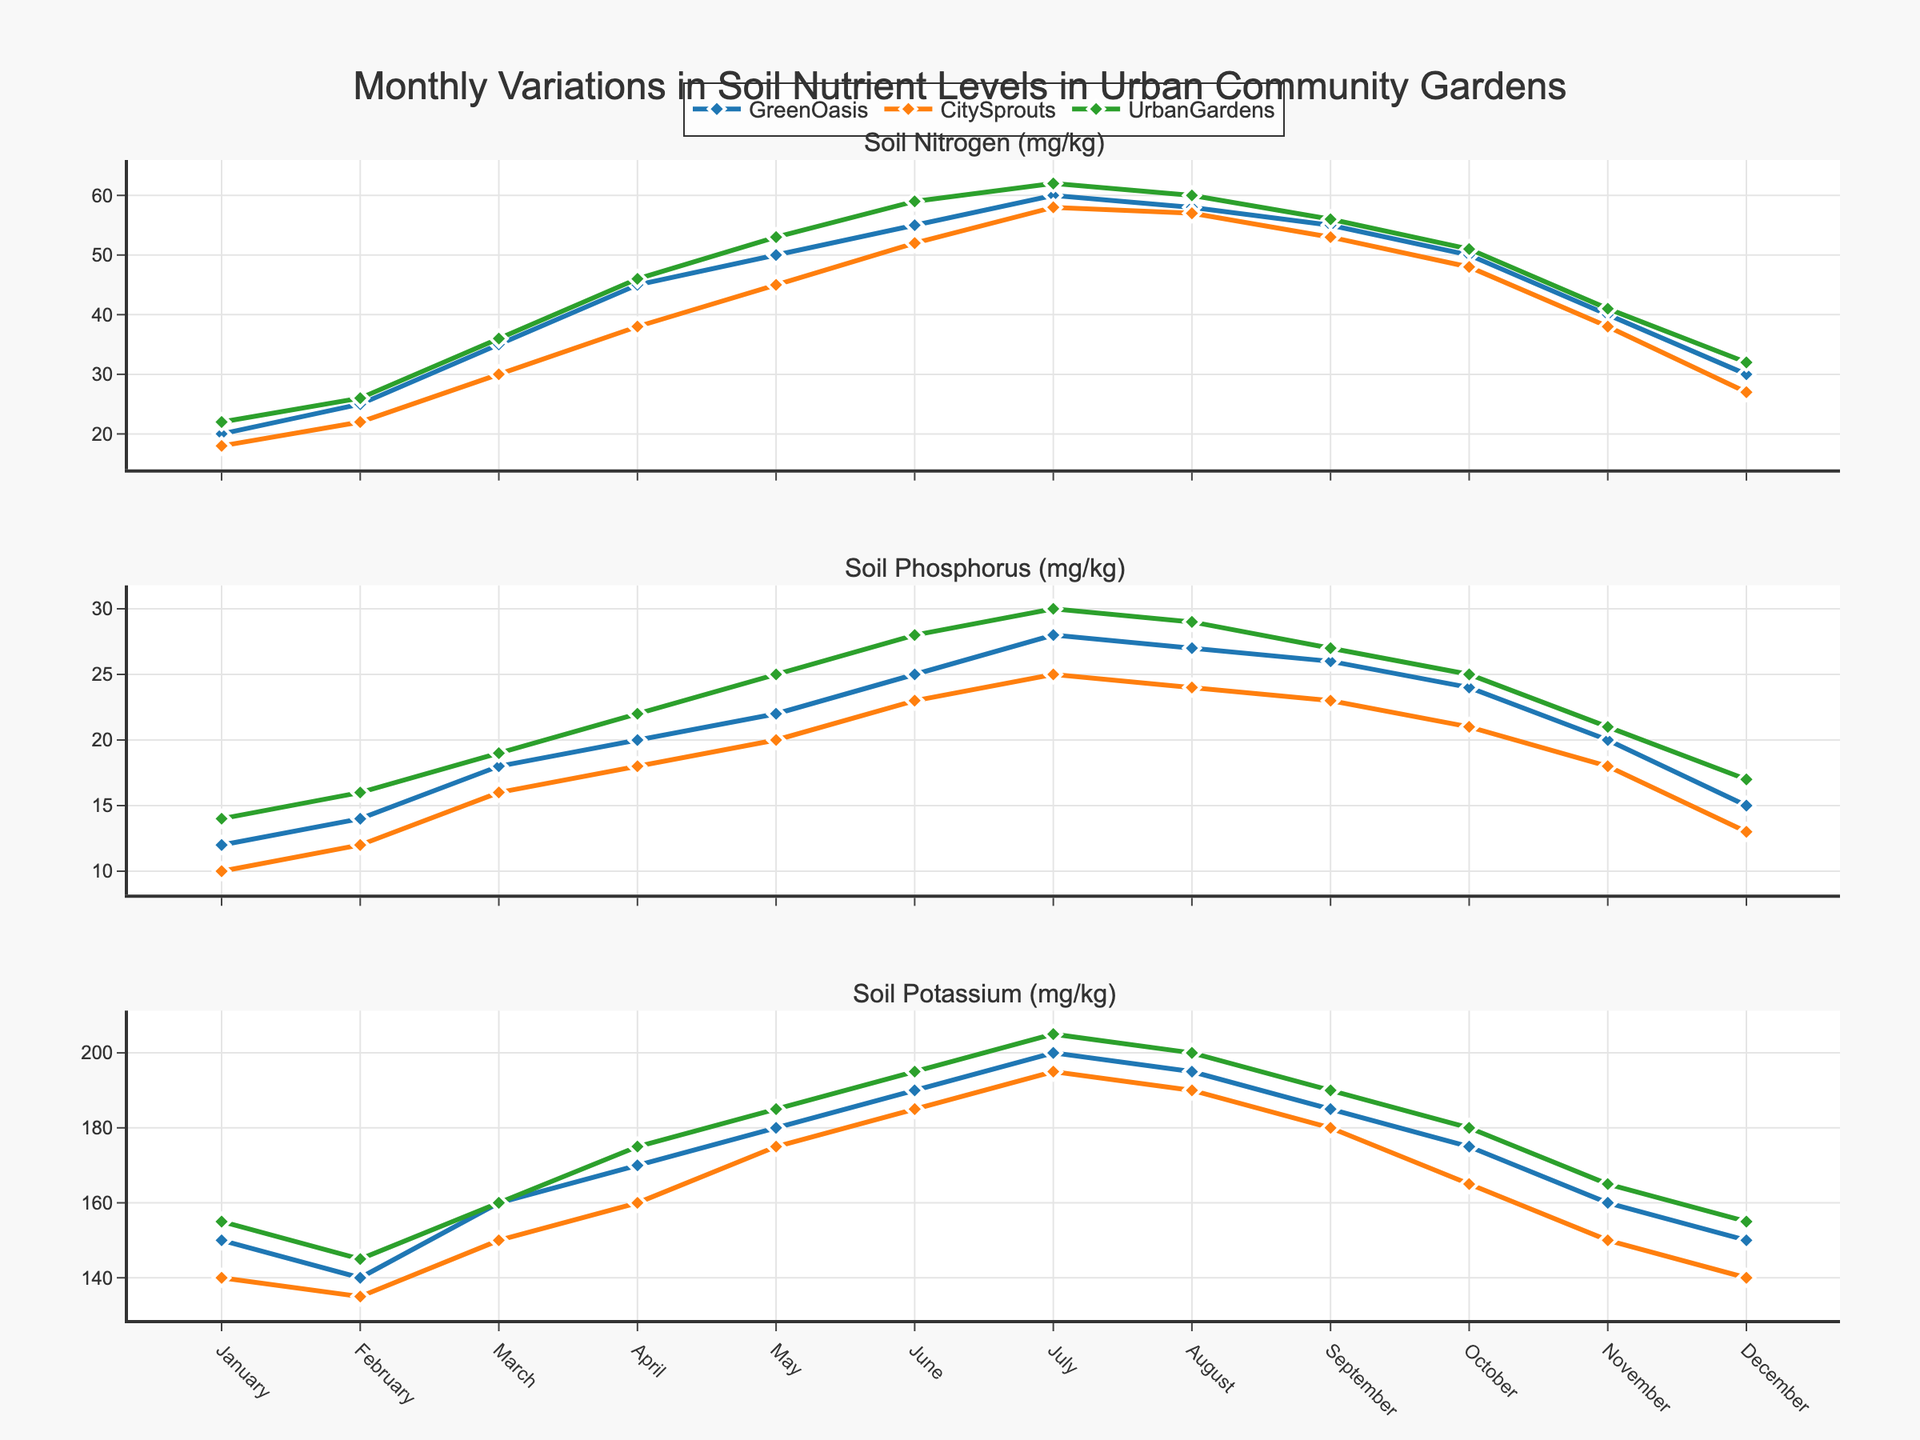Which month has the highest soil nitrogen level in GreenOasis? Look at the soil nitrogen trace for GreenOasis and identify the peak point, which occurs in July.
Answer: July What is the difference in soil phosphorus levels between March and October in CitySprouts? Identify the phosphorus levels in March (16 mg/kg) and October (21 mg/kg) for CitySprouts, then calculate the difference: 21 - 16 = 5 mg/kg.
Answer: 5 mg/kg How do the potassium levels in December compare across the three gardens? Examine the trace for potassium levels in December for each garden: GreenOasis (150 mg/kg), CitySprouts (140 mg/kg), UrbanGardens (155 mg/kg). UrbanGardens has the highest, followed by GreenOasis, and CitySprouts has the lowest.
Answer: UrbanGardens > GreenOasis > CitySprouts Which garden shows the most significant increase in soil nitrogen levels from January to June? Compare the increase in soil nitrogen levels from January (GreenOasis: 20 mg/kg, CitySprouts: 18 mg/kg, UrbanGardens: 22 mg/kg) to June (GreenOasis: 55 mg/kg, CitySprouts: 52 mg/kg, UrbanGardens: 59 mg/kg) for each garden. The increases are: GreenOasis = 35 mg/kg, CitySprouts = 34 mg/kg, UrbanGardens = 37 mg/kg.
Answer: UrbanGardens During which month does CitySprouts show the highest soil potassium level? Identify the peak in the potassium level trace for CitySprouts, which occurs in July at 195 mg/kg.
Answer: July What is the average soil nitrogen level in UrbanGardens during the summer months (June, July, August)? Identify the nitrogen levels in June (59 mg/kg), July (62 mg/kg), and August (60 mg/kg), then calculate the average: (59 + 62 + 60) / 3 = 60.33 mg/kg.
Answer: 60.33 mg/kg Comparing GreenOasis and CitySprouts, which garden has consistently higher soil phosphorus levels during the growing season (April to October)? Evaluate the phosphorus levels in GreenOasis and CitySprouts from April to October. GreenOasis consistently has higher levels: April (20 vs 18), May (22 vs 20), June (25 vs 23), July (28 vs 25), August (27 vs 24), September (26 vs 23), October (24 vs 21).
Answer: GreenOasis What is the trend of soil nitrogen levels in UrbanGardens from April to November? Observe the trace for nitrogen in UrbanGardens from April to November: April (46 mg/kg), May (53 mg/kg), June (59 mg/kg), July (62 mg/kg), August (60 mg/kg), September (56 mg/kg), October (51 mg/kg), November (41 mg/kg). The trend shows an initial increase till July followed by a gradual decrease.
Answer: Increase till July, then decrease Which garden has the least variation in soil potassium levels over the year? Examine the potassium level traces for each garden and compare the ranges (max - min): GreenOasis (200 - 140 = 60), CitySprouts (195 - 135 = 60), UrbanGardens (205 - 145 = 60). All gardens have the same level of variation.
Answer: All the same 